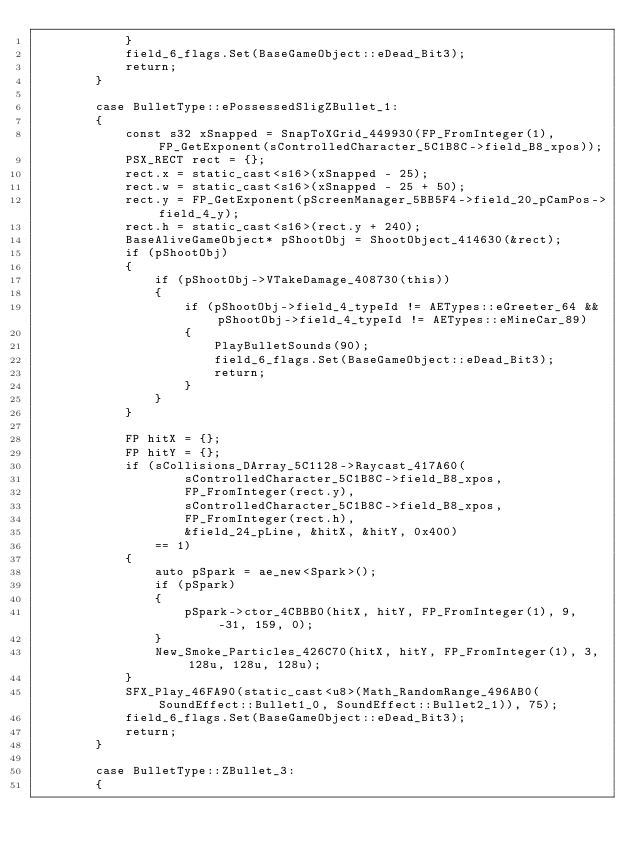<code> <loc_0><loc_0><loc_500><loc_500><_C++_>            }
            field_6_flags.Set(BaseGameObject::eDead_Bit3);
            return;
        }

        case BulletType::ePossessedSligZBullet_1:
        {
            const s32 xSnapped = SnapToXGrid_449930(FP_FromInteger(1), FP_GetExponent(sControlledCharacter_5C1B8C->field_B8_xpos));
            PSX_RECT rect = {};
            rect.x = static_cast<s16>(xSnapped - 25);
            rect.w = static_cast<s16>(xSnapped - 25 + 50);
            rect.y = FP_GetExponent(pScreenManager_5BB5F4->field_20_pCamPos->field_4_y);
            rect.h = static_cast<s16>(rect.y + 240);
            BaseAliveGameObject* pShootObj = ShootObject_414630(&rect);
            if (pShootObj)
            {
                if (pShootObj->VTakeDamage_408730(this))
                {
                    if (pShootObj->field_4_typeId != AETypes::eGreeter_64 && pShootObj->field_4_typeId != AETypes::eMineCar_89)
                    {
                        PlayBulletSounds(90);
                        field_6_flags.Set(BaseGameObject::eDead_Bit3);
                        return;
                    }
                }
            }

            FP hitX = {};
            FP hitY = {};
            if (sCollisions_DArray_5C1128->Raycast_417A60(
                    sControlledCharacter_5C1B8C->field_B8_xpos,
                    FP_FromInteger(rect.y),
                    sControlledCharacter_5C1B8C->field_B8_xpos,
                    FP_FromInteger(rect.h),
                    &field_24_pLine, &hitX, &hitY, 0x400)
                == 1)
            {
                auto pSpark = ae_new<Spark>();
                if (pSpark)
                {
                    pSpark->ctor_4CBBB0(hitX, hitY, FP_FromInteger(1), 9, -31, 159, 0);
                }
                New_Smoke_Particles_426C70(hitX, hitY, FP_FromInteger(1), 3, 128u, 128u, 128u);
            }
            SFX_Play_46FA90(static_cast<u8>(Math_RandomRange_496AB0(SoundEffect::Bullet1_0, SoundEffect::Bullet2_1)), 75);
            field_6_flags.Set(BaseGameObject::eDead_Bit3);
            return;
        }

        case BulletType::ZBullet_3:
        {</code> 